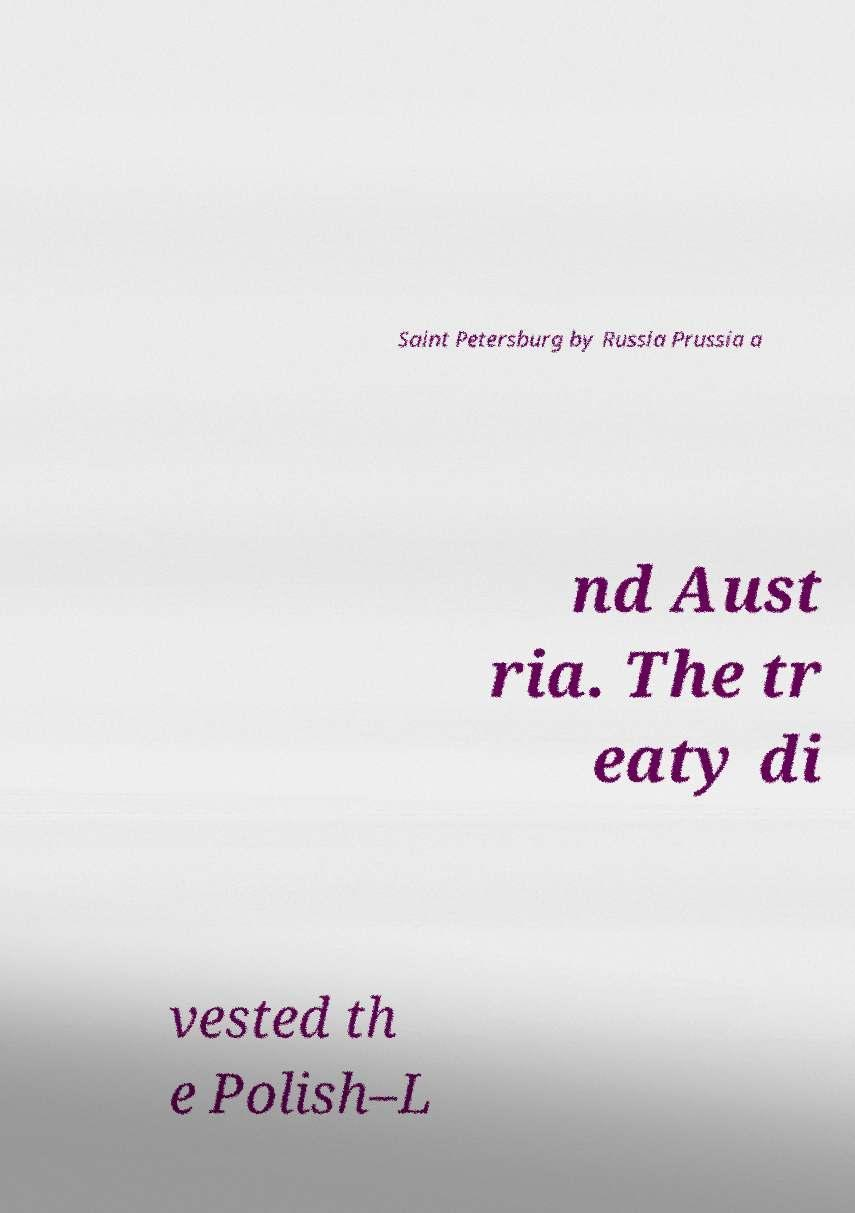Could you assist in decoding the text presented in this image and type it out clearly? Saint Petersburg by Russia Prussia a nd Aust ria. The tr eaty di vested th e Polish–L 